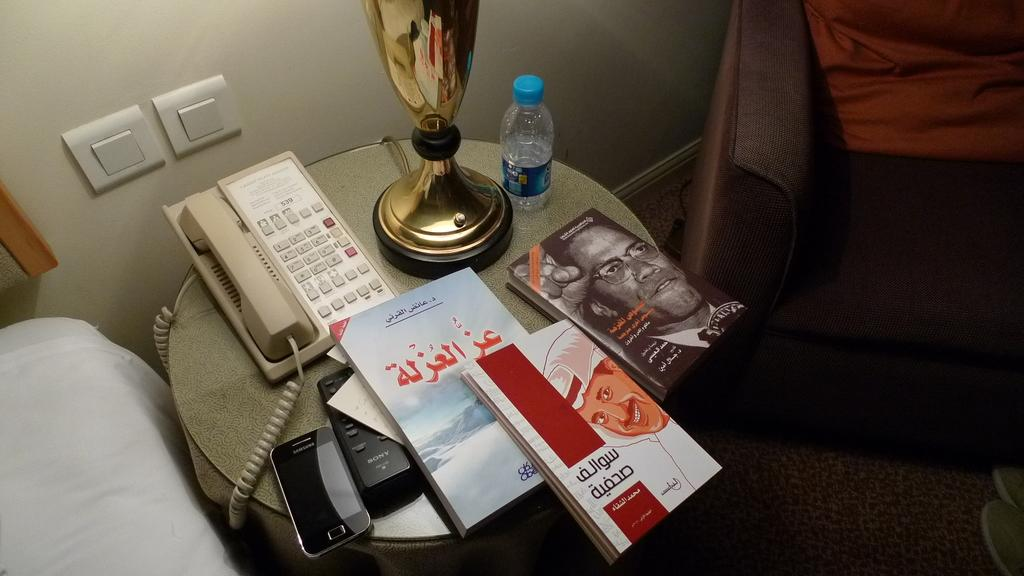<image>
Write a terse but informative summary of the picture. On a bedside table are a Samsung phone and a Sony remote. 